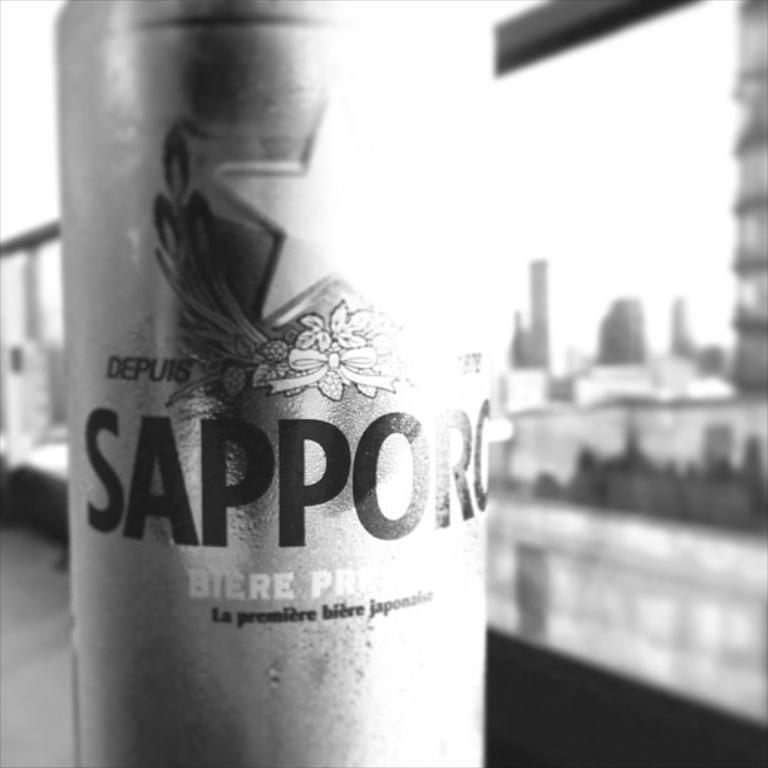<image>
Share a concise interpretation of the image provided. A beverage on a table in a bottle that says Sapporg on it. 